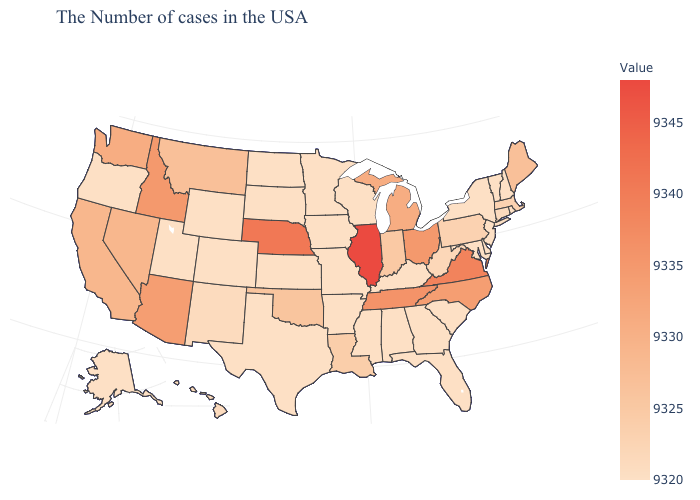Among the states that border New Jersey , does Delaware have the lowest value?
Write a very short answer. Yes. Does Kansas have the lowest value in the USA?
Short answer required. Yes. Does Illinois have the highest value in the USA?
Keep it brief. Yes. Is the legend a continuous bar?
Give a very brief answer. Yes. Does Illinois have the highest value in the USA?
Answer briefly. Yes. Does Florida have the lowest value in the USA?
Answer briefly. Yes. Does Montana have the lowest value in the West?
Be succinct. No. Does California have the lowest value in the USA?
Short answer required. No. 